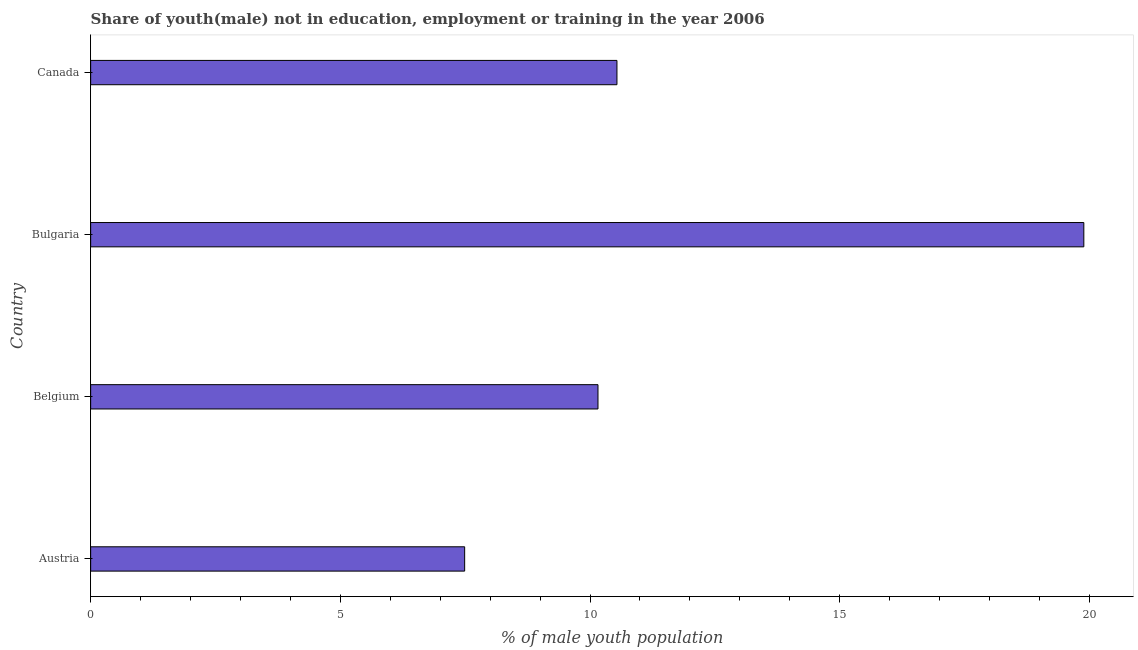Does the graph contain grids?
Make the answer very short. No. What is the title of the graph?
Your response must be concise. Share of youth(male) not in education, employment or training in the year 2006. What is the label or title of the X-axis?
Provide a short and direct response. % of male youth population. What is the label or title of the Y-axis?
Offer a very short reply. Country. What is the unemployed male youth population in Bulgaria?
Your answer should be compact. 19.89. Across all countries, what is the maximum unemployed male youth population?
Keep it short and to the point. 19.89. Across all countries, what is the minimum unemployed male youth population?
Your answer should be compact. 7.49. In which country was the unemployed male youth population minimum?
Provide a short and direct response. Austria. What is the sum of the unemployed male youth population?
Your response must be concise. 48.08. What is the difference between the unemployed male youth population in Austria and Canada?
Your answer should be compact. -3.05. What is the average unemployed male youth population per country?
Your answer should be very brief. 12.02. What is the median unemployed male youth population?
Provide a succinct answer. 10.35. In how many countries, is the unemployed male youth population greater than 5 %?
Offer a terse response. 4. What is the difference between the highest and the second highest unemployed male youth population?
Ensure brevity in your answer.  9.35. Is the sum of the unemployed male youth population in Belgium and Bulgaria greater than the maximum unemployed male youth population across all countries?
Make the answer very short. Yes. In how many countries, is the unemployed male youth population greater than the average unemployed male youth population taken over all countries?
Keep it short and to the point. 1. How many bars are there?
Your response must be concise. 4. Are all the bars in the graph horizontal?
Your response must be concise. Yes. What is the % of male youth population of Austria?
Make the answer very short. 7.49. What is the % of male youth population of Belgium?
Ensure brevity in your answer.  10.16. What is the % of male youth population in Bulgaria?
Make the answer very short. 19.89. What is the % of male youth population of Canada?
Your response must be concise. 10.54. What is the difference between the % of male youth population in Austria and Belgium?
Your answer should be compact. -2.67. What is the difference between the % of male youth population in Austria and Canada?
Give a very brief answer. -3.05. What is the difference between the % of male youth population in Belgium and Bulgaria?
Your answer should be compact. -9.73. What is the difference between the % of male youth population in Belgium and Canada?
Offer a very short reply. -0.38. What is the difference between the % of male youth population in Bulgaria and Canada?
Keep it short and to the point. 9.35. What is the ratio of the % of male youth population in Austria to that in Belgium?
Keep it short and to the point. 0.74. What is the ratio of the % of male youth population in Austria to that in Bulgaria?
Ensure brevity in your answer.  0.38. What is the ratio of the % of male youth population in Austria to that in Canada?
Make the answer very short. 0.71. What is the ratio of the % of male youth population in Belgium to that in Bulgaria?
Your response must be concise. 0.51. What is the ratio of the % of male youth population in Bulgaria to that in Canada?
Your answer should be compact. 1.89. 